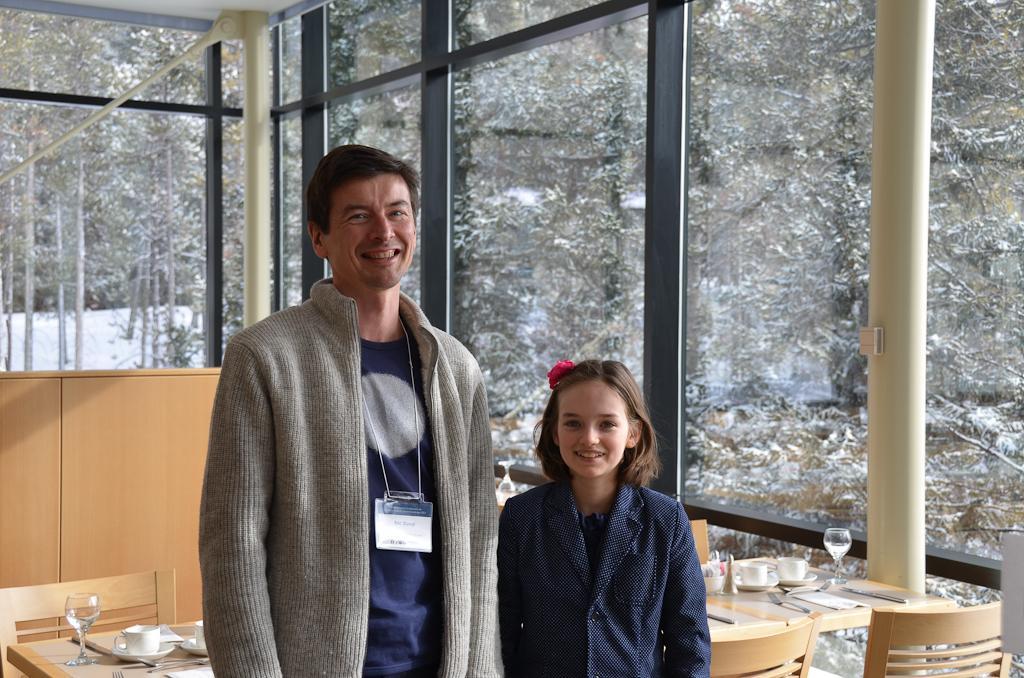How would you summarize this image in a sentence or two? In this picture we can see man and a girl standing and they are smiling and beside to them there is table and on table we can see cup, saucer, glass, papers, chairs and in background we can see trees, pillar, wall. 